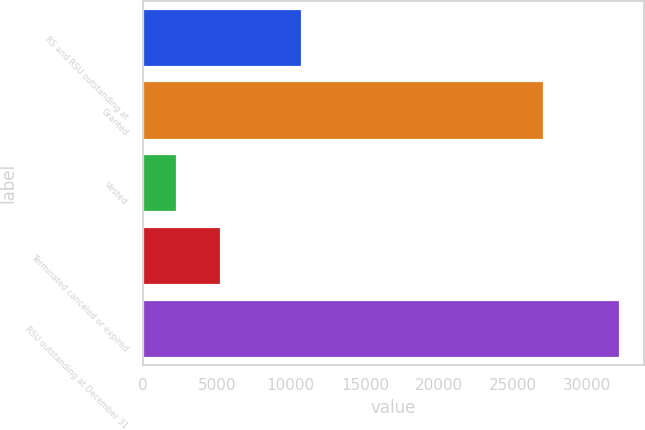Convert chart to OTSL. <chart><loc_0><loc_0><loc_500><loc_500><bar_chart><fcel>RS and RSU outstanding at<fcel>Granted<fcel>Vested<fcel>Terminated canceled or expired<fcel>RSU outstanding at December 31<nl><fcel>10755<fcel>27102<fcel>2308<fcel>5300.2<fcel>32230<nl></chart> 